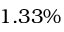<formula> <loc_0><loc_0><loc_500><loc_500>1 . 3 3 \%</formula> 